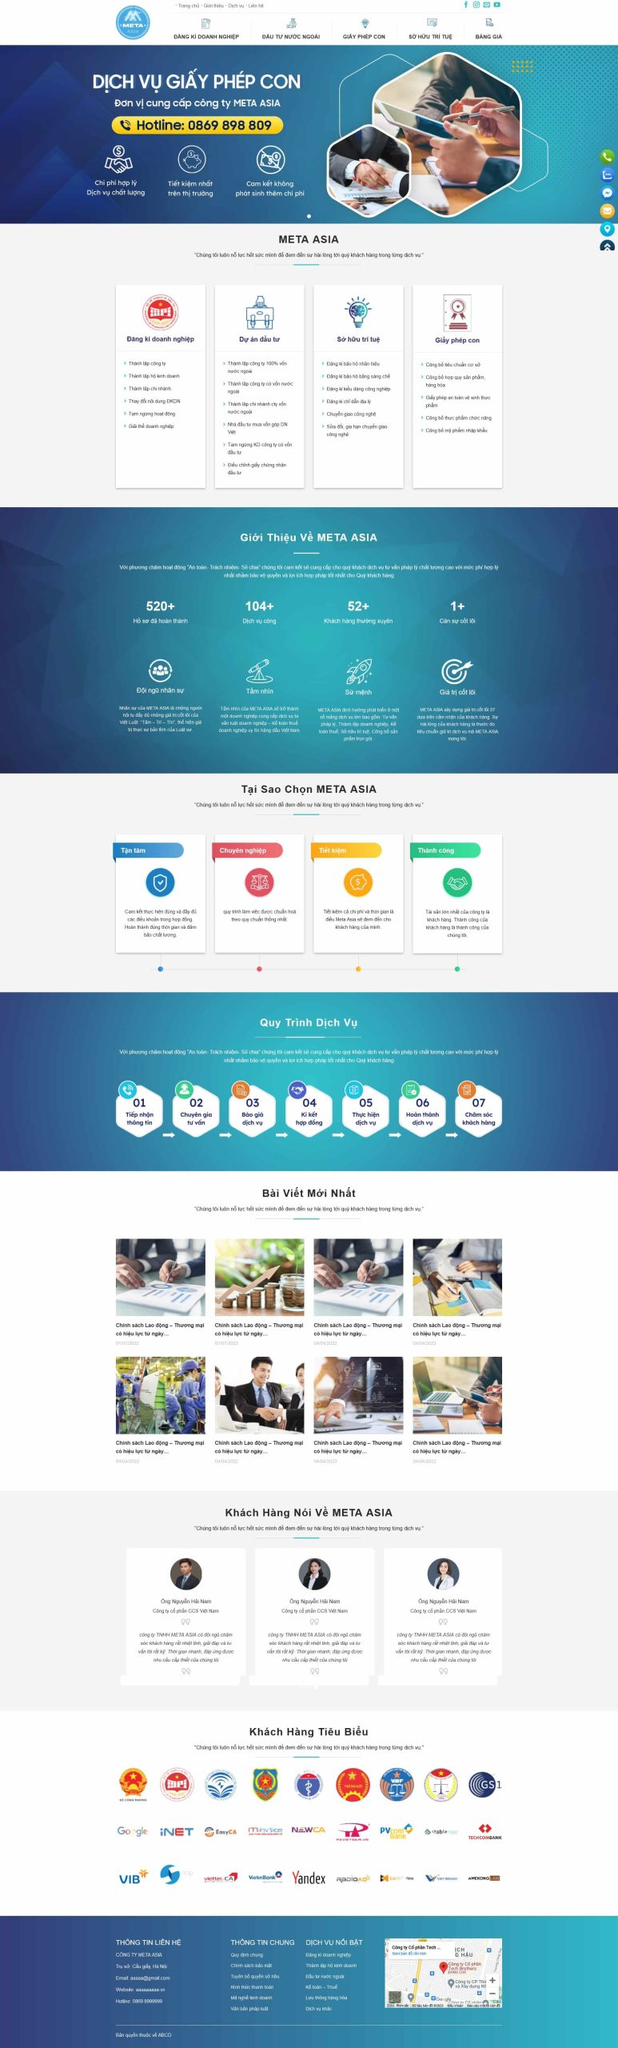Liệt kê 5 ngành nghề, lĩnh vực phù hợp với website này, phân cách các màu sắc bằng dấu phẩy. Chỉ trả về kết quả, phân cách bằng dấy phẩy
 Đăng ký doanh nghiệp, Đầu tư nước ngoài, Sở hữu trí tuệ, Giấy phép con, Tư vấn doanh nghiệp 